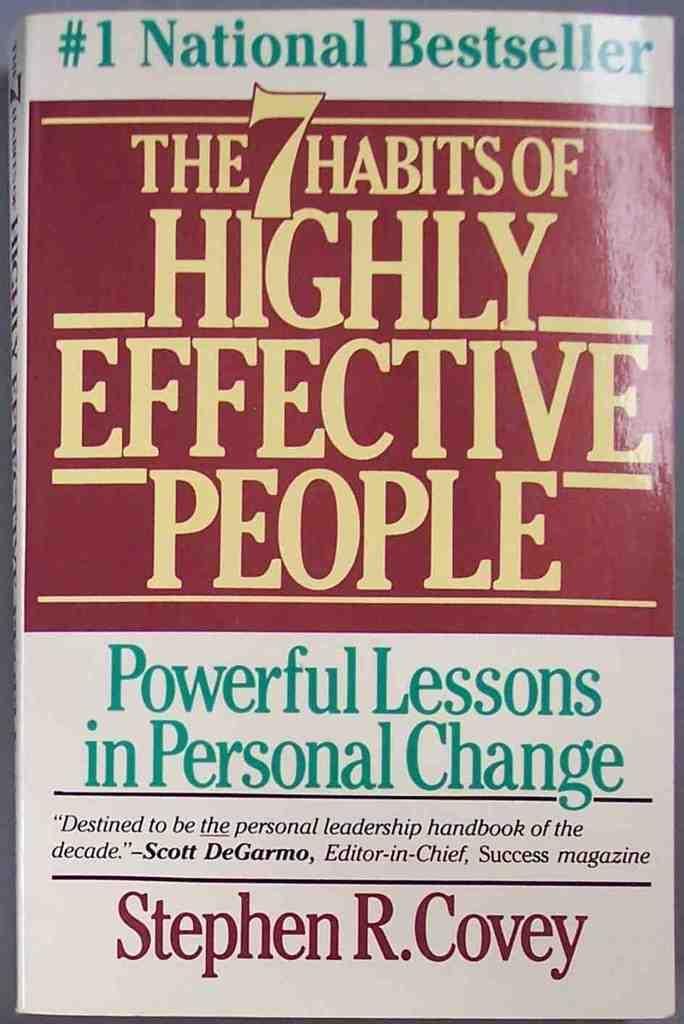<image>
Share a concise interpretation of the image provided. A book called The 7 Habits of Highly Effective People. 